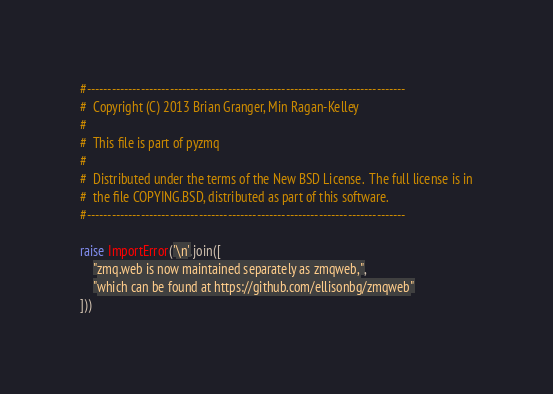Convert code to text. <code><loc_0><loc_0><loc_500><loc_500><_Python_>#-----------------------------------------------------------------------------
#  Copyright (C) 2013 Brian Granger, Min Ragan-Kelley
#
#  This file is part of pyzmq
#
#  Distributed under the terms of the New BSD License.  The full license is in
#  the file COPYING.BSD, distributed as part of this software.
#-----------------------------------------------------------------------------

raise ImportError('\n'.join([
    "zmq.web is now maintained separately as zmqweb,",
    "which can be found at https://github.com/ellisonbg/zmqweb"
]))
</code> 